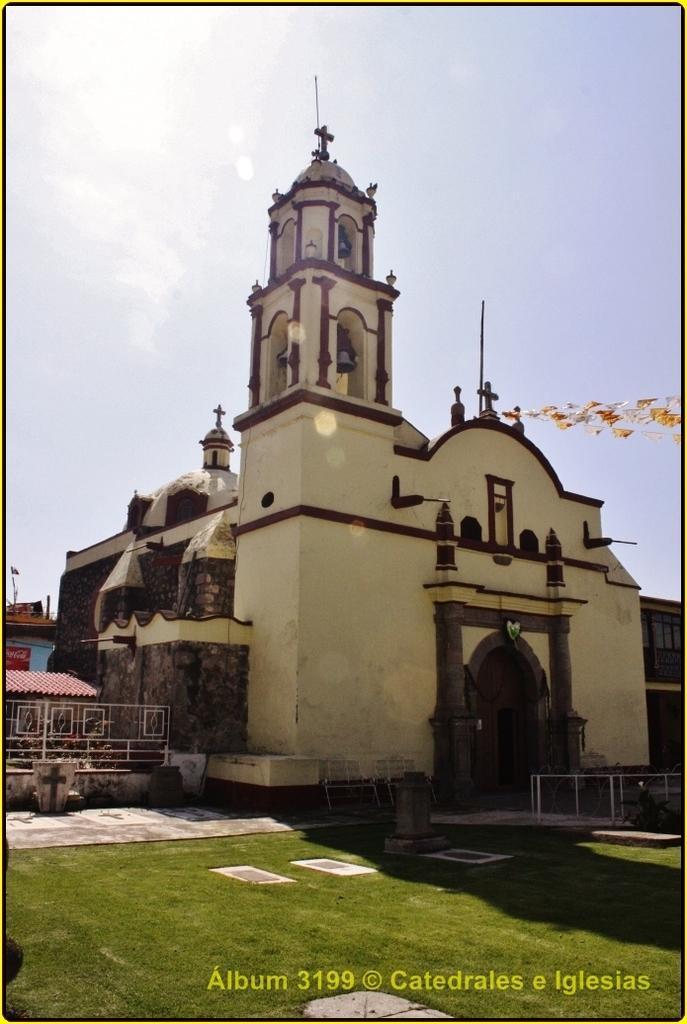Can you describe this image briefly? In this image I can see a building in brown and cream color, grass in green color. Background the sky is in white color. 